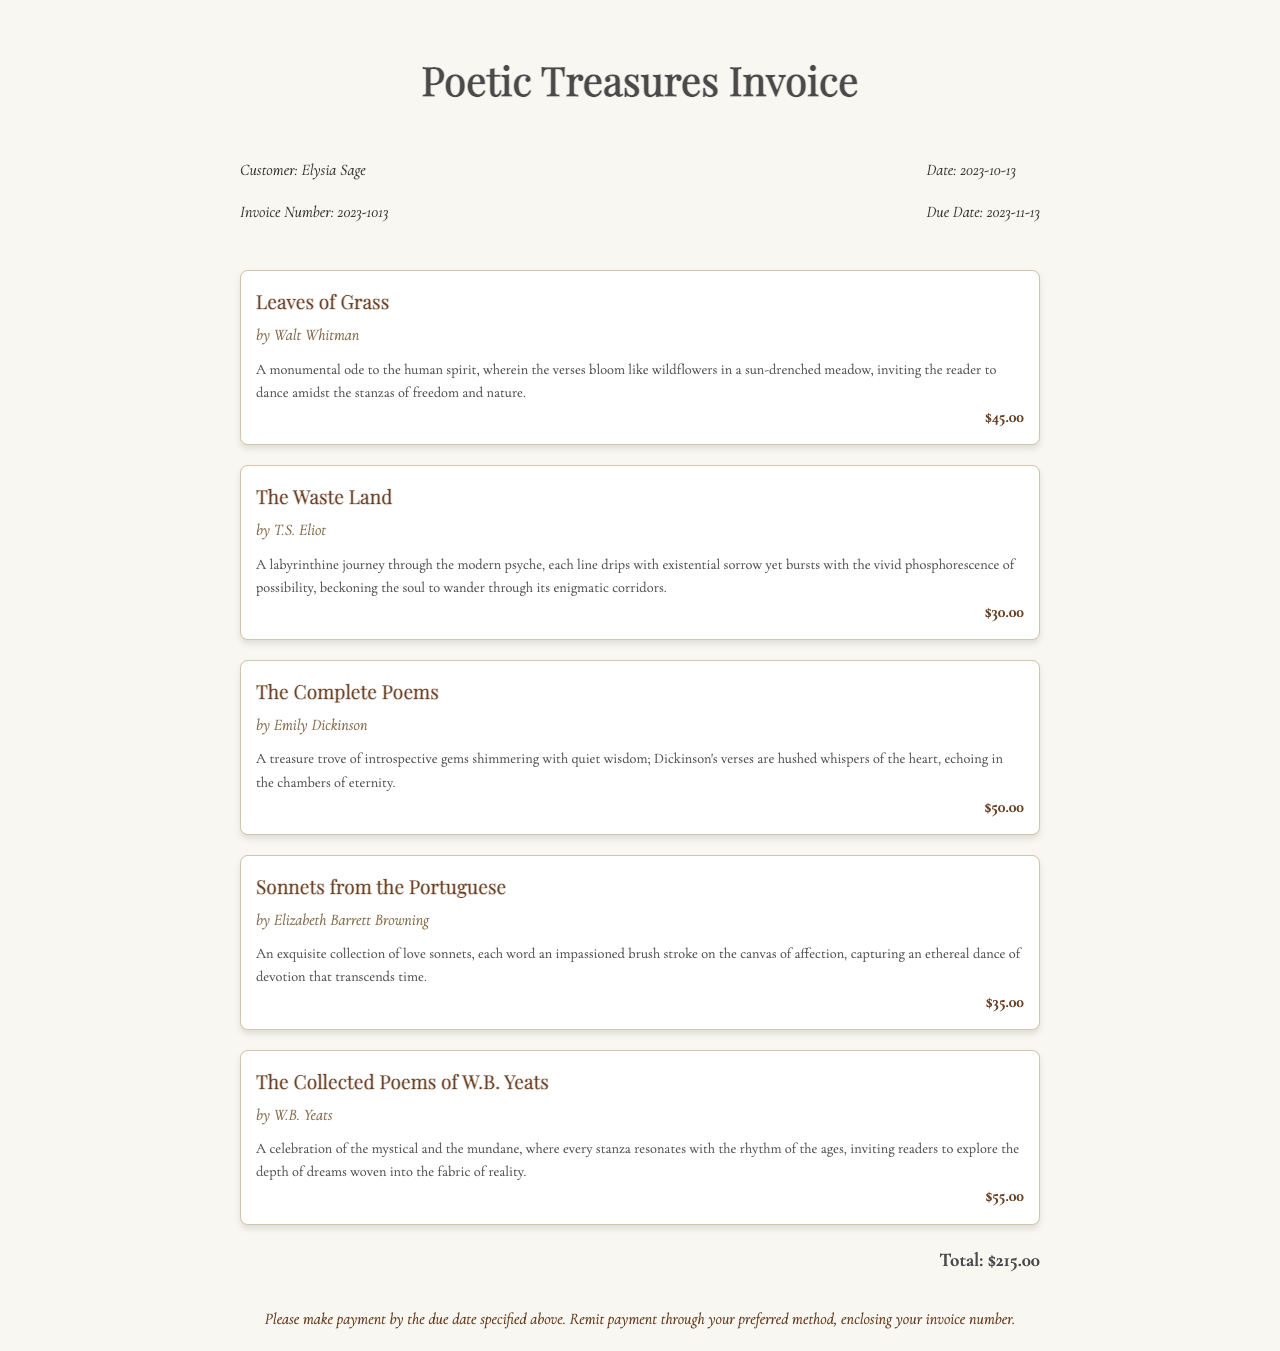What is the invoice number? The invoice number is explicitly stated in the document for identification purposes.
Answer: 2023-1013 What is the date of the invoice? The date on the invoice marks when the transaction is recorded and is distinctly noted in the document.
Answer: 2023-10-13 Who is the customer? The name of the individual or entity the invoice is addressed to is provided in the document.
Answer: Elysia Sage What is the total cost of the books? The total cost of all the items listed on the invoice can be found at the bottom of the document.
Answer: $215.00 How many books are included in the invoice? The number of distinct book items specified within the document is essential for understanding the order.
Answer: 5 What is the payment due date? The due date indicates when payment should be made and is mentioned clearly in the document.
Answer: 2023-11-13 Which book costs the most? This information requires comparing the listed prices of the items provided in the invoice.
Answer: The Collected Poems of W.B. Yeats What is the author of "Sonnets from the Portuguese"? The author of each book is specified in the invoice, making it easy to retrieve.
Answer: Elizabeth Barrett Browning What genre do all the listed books fall under? While the invoice does indicate specific titles, the overarching theme is based on literary works, likely poetry.
Answer: Poetry 